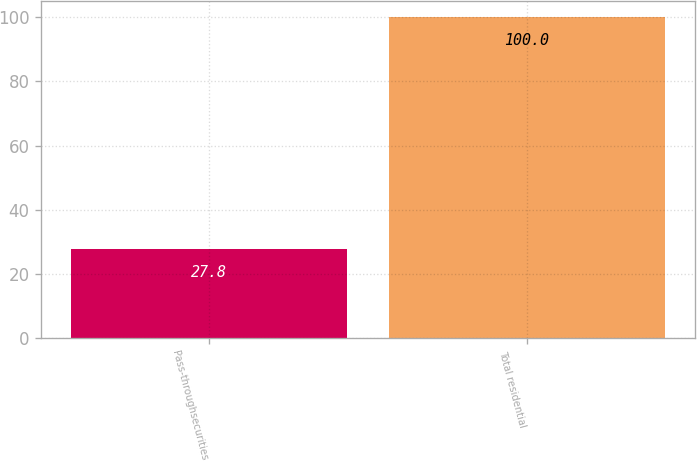Convert chart. <chart><loc_0><loc_0><loc_500><loc_500><bar_chart><fcel>Pass-throughsecurities<fcel>Total residential<nl><fcel>27.8<fcel>100<nl></chart> 